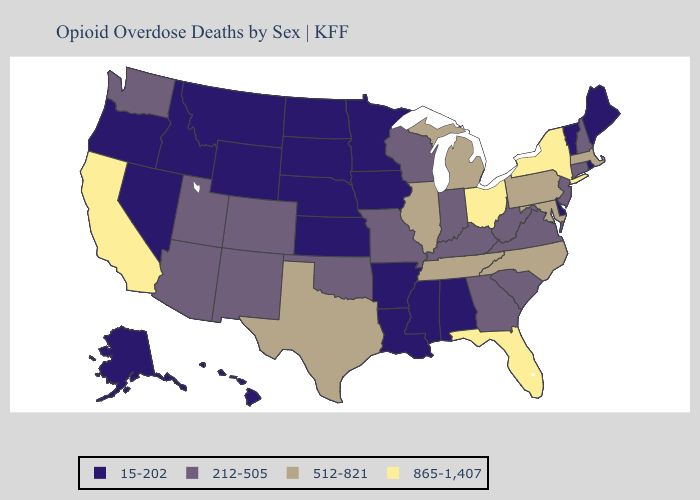What is the value of Kansas?
Short answer required. 15-202. Among the states that border Indiana , does Michigan have the lowest value?
Short answer required. No. Name the states that have a value in the range 512-821?
Give a very brief answer. Illinois, Maryland, Massachusetts, Michigan, North Carolina, Pennsylvania, Tennessee, Texas. Does Maine have the lowest value in the USA?
Answer briefly. Yes. What is the value of Massachusetts?
Keep it brief. 512-821. Name the states that have a value in the range 512-821?
Be succinct. Illinois, Maryland, Massachusetts, Michigan, North Carolina, Pennsylvania, Tennessee, Texas. Name the states that have a value in the range 512-821?
Answer briefly. Illinois, Maryland, Massachusetts, Michigan, North Carolina, Pennsylvania, Tennessee, Texas. Which states hav the highest value in the Northeast?
Answer briefly. New York. What is the value of Nevada?
Concise answer only. 15-202. Which states have the highest value in the USA?
Give a very brief answer. California, Florida, New York, Ohio. Among the states that border Minnesota , which have the highest value?
Give a very brief answer. Wisconsin. Which states have the lowest value in the South?
Short answer required. Alabama, Arkansas, Delaware, Louisiana, Mississippi. Name the states that have a value in the range 512-821?
Keep it brief. Illinois, Maryland, Massachusetts, Michigan, North Carolina, Pennsylvania, Tennessee, Texas. What is the value of Pennsylvania?
Short answer required. 512-821. 